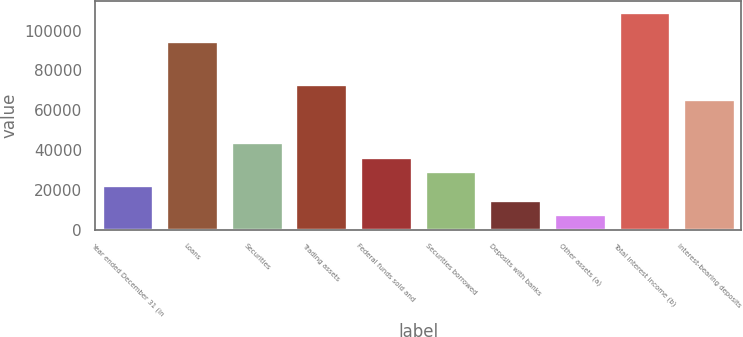Convert chart. <chart><loc_0><loc_0><loc_500><loc_500><bar_chart><fcel>Year ended December 31 (in<fcel>Loans<fcel>Securities<fcel>Trading assets<fcel>Federal funds sold and<fcel>Securities borrowed<fcel>Deposits with banks<fcel>Other assets (a)<fcel>Total interest income (b)<fcel>Interest-bearing deposits<nl><fcel>22188.9<fcel>94801.9<fcel>43972.8<fcel>73018<fcel>36711.5<fcel>29450.2<fcel>14927.6<fcel>7666.3<fcel>109324<fcel>65756.7<nl></chart> 